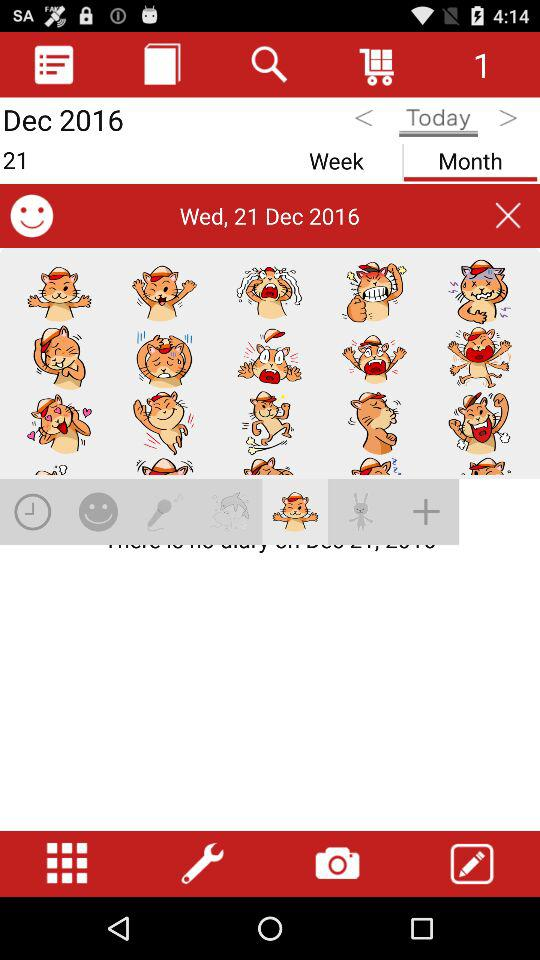What date is selected? The selected date is Wednesday, December 21, 2016. 